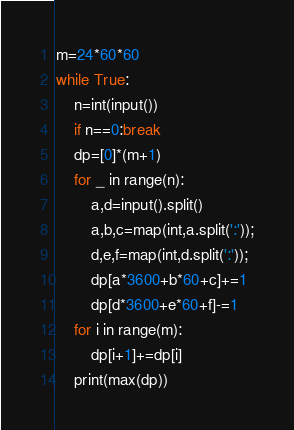Convert code to text. <code><loc_0><loc_0><loc_500><loc_500><_Python_>m=24*60*60
while True:
	n=int(input())
	if n==0:break
	dp=[0]*(m+1)
	for _ in range(n):
		a,d=input().split()
		a,b,c=map(int,a.split(':'));
		d,e,f=map(int,d.split(':'));
		dp[a*3600+b*60+c]+=1
		dp[d*3600+e*60+f]-=1
	for i in range(m):
		dp[i+1]+=dp[i]
	print(max(dp))</code> 